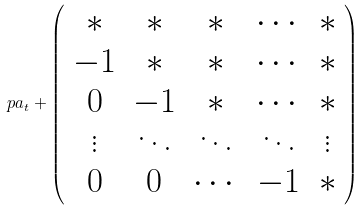<formula> <loc_0><loc_0><loc_500><loc_500>\ p a _ { t } + \left ( \begin{array} { c c c c c } * & * & * & \cdots & * \\ - 1 & * & * & \cdots & * \\ 0 & - 1 & * & \cdots & * \\ \vdots & \ddots & \ddots & \ddots & \vdots \\ 0 & 0 & \cdots & - 1 & * \end{array} \right )</formula> 